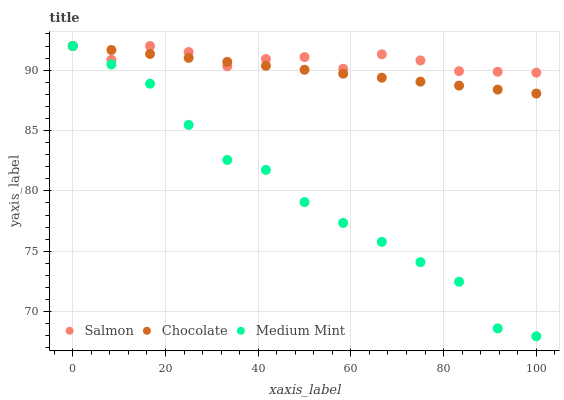Does Medium Mint have the minimum area under the curve?
Answer yes or no. Yes. Does Salmon have the maximum area under the curve?
Answer yes or no. Yes. Does Chocolate have the minimum area under the curve?
Answer yes or no. No. Does Chocolate have the maximum area under the curve?
Answer yes or no. No. Is Chocolate the smoothest?
Answer yes or no. Yes. Is Salmon the roughest?
Answer yes or no. Yes. Is Salmon the smoothest?
Answer yes or no. No. Is Chocolate the roughest?
Answer yes or no. No. Does Medium Mint have the lowest value?
Answer yes or no. Yes. Does Chocolate have the lowest value?
Answer yes or no. No. Does Chocolate have the highest value?
Answer yes or no. Yes. Does Salmon intersect Medium Mint?
Answer yes or no. Yes. Is Salmon less than Medium Mint?
Answer yes or no. No. Is Salmon greater than Medium Mint?
Answer yes or no. No. 